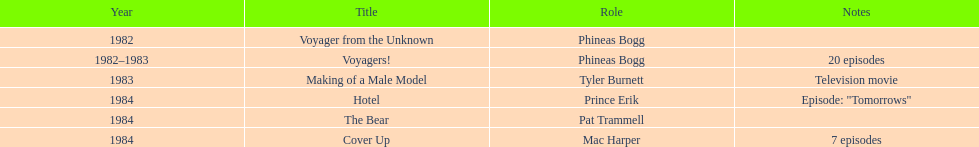Which year did he play the role of mac harper and also pat trammell? 1984. 